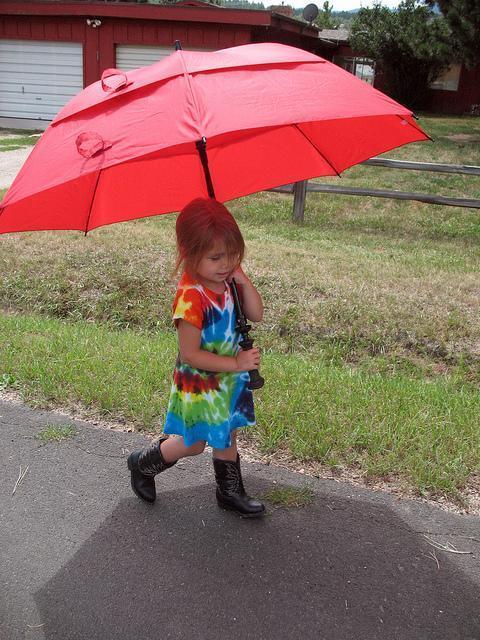How many umbrellas can be seen?
Give a very brief answer. 1. 